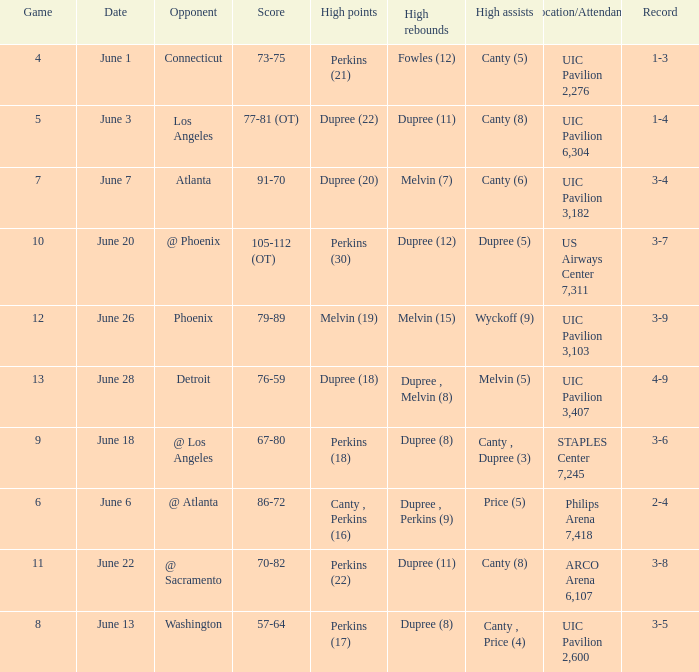What is the date of game 9? June 18. 